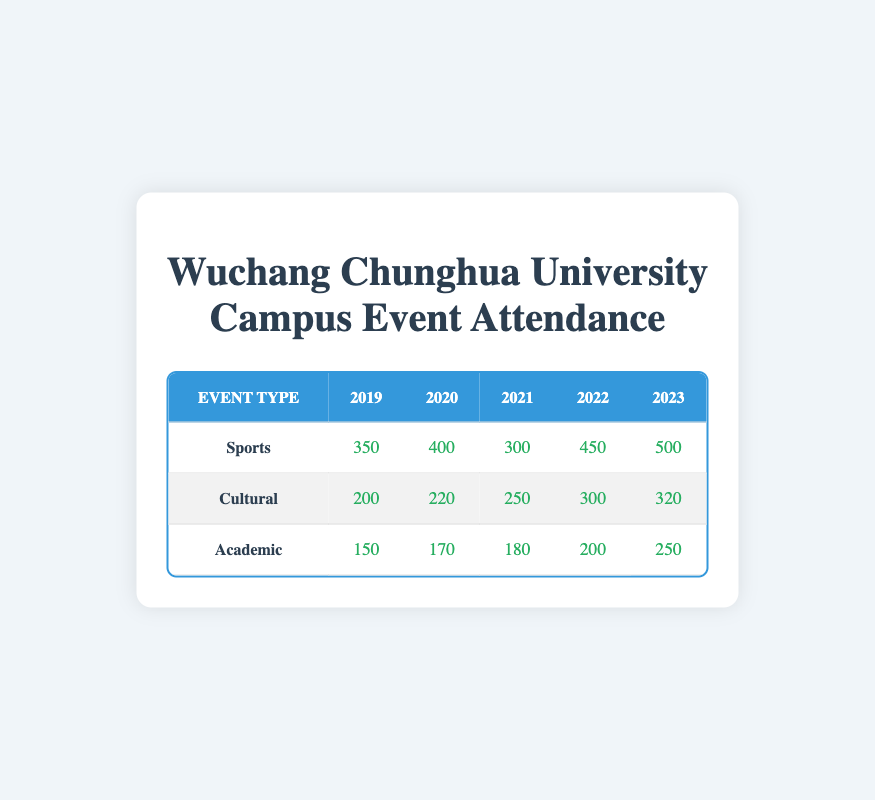What was the attendance for the Cultural event in 2021? Referring to the table, the Cultural event attendance for 2021 is directly indicated in the cell corresponding to that year and event type, which is 250.
Answer: 250 How much did the attendance for Sports events increase from 2019 to 2022? The Sports event attendance for 2019 is 350 and for 2022 is 450. The increase can be calculated as 450 - 350 = 100.
Answer: 100 Was the attendance for Academic events in 2023 greater than in 2019? In 2023, the attendance for Academic events is 250, while in 2019 it was 150. Since 250 is greater than 150, the statement is true.
Answer: Yes Which year had the highest attendance for Cultural events? Checking the Cultural event attendances across the years: 200 in 2019, 220 in 2020, 250 in 2021, 300 in 2022, and 320 in 2023. The highest value is 320 in the year 2023.
Answer: 2023 What is the total attendance for Academic events from 2019 to 2023? The Academic event attendances are as follows: 150 (2019), 170 (2020), 180 (2021), 200 (2022), and 250 (2023). To find the total, we add these values: 150 + 170 + 180 + 200 + 250 = 950.
Answer: 950 In which year did the attendance for Sports events drop compared to the previous year? The attendances for Sports events are: 350 (2019), 400 (2020), 300 (2021), 450 (2022), and 500 (2023). The only decrease occurs from 2020 (400) to 2021 (300).
Answer: 2021 Which event type had the lowest attendance in 2022? Checking the attendance values for each event type in 2022: Sports 450, Cultural 300, and Academic 200. The lowest attendance is for Academic events which had 200.
Answer: Academic What was the average attendance for Cultural events from 2019 to 2023? The attendances for Cultural events are: 200 (2019), 220 (2020), 250 (2021), 300 (2022), and 320 (2023). To calculate the average, sum them up: 200 + 220 + 250 + 300 + 320 = 1290, and divide by 5: 1290 / 5 = 258.
Answer: 258 In 2020, did the Sports event attendance exceed that of Academic events? The Sports event attendance in 2020 is 400 and for Academic events it is 170. Since 400 is greater than 170, the statement is true.
Answer: Yes 